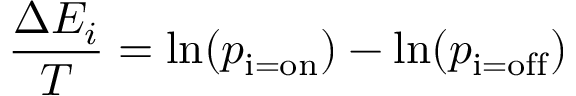<formula> <loc_0><loc_0><loc_500><loc_500>{ \frac { \Delta E _ { i } } { T } } = \ln ( p _ { i = o n } ) - \ln ( p _ { i = o f f } )</formula> 